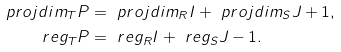<formula> <loc_0><loc_0><loc_500><loc_500>\ p r o j d i m _ { T } P & = \ p r o j d i m _ { R } I + \ p r o j d i m _ { S } J + 1 , \\ \ r e g _ { T } P & = \ r e g _ { R } I + \ r e g _ { S } J - 1 .</formula> 